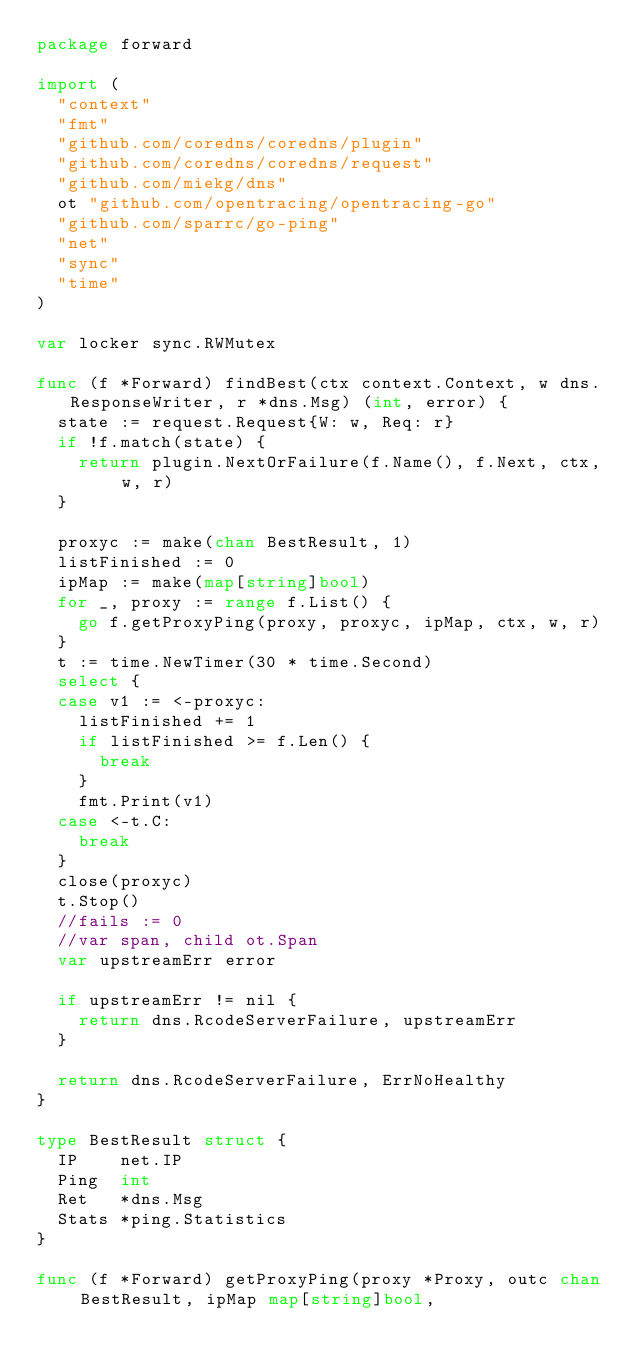Convert code to text. <code><loc_0><loc_0><loc_500><loc_500><_Go_>package forward

import (
	"context"
	"fmt"
	"github.com/coredns/coredns/plugin"
	"github.com/coredns/coredns/request"
	"github.com/miekg/dns"
	ot "github.com/opentracing/opentracing-go"
	"github.com/sparrc/go-ping"
	"net"
	"sync"
	"time"
)

var locker sync.RWMutex

func (f *Forward) findBest(ctx context.Context, w dns.ResponseWriter, r *dns.Msg) (int, error) {
	state := request.Request{W: w, Req: r}
	if !f.match(state) {
		return plugin.NextOrFailure(f.Name(), f.Next, ctx, w, r)
	}

	proxyc := make(chan BestResult, 1)
	listFinished := 0
	ipMap := make(map[string]bool)
	for _, proxy := range f.List() {
		go f.getProxyPing(proxy, proxyc, ipMap, ctx, w, r)
	}
	t := time.NewTimer(30 * time.Second)
	select {
	case v1 := <-proxyc:
		listFinished += 1
		if listFinished >= f.Len() {
			break
		}
		fmt.Print(v1)
	case <-t.C:
		break
	}
	close(proxyc)
	t.Stop()
	//fails := 0
	//var span, child ot.Span
	var upstreamErr error

	if upstreamErr != nil {
		return dns.RcodeServerFailure, upstreamErr
	}

	return dns.RcodeServerFailure, ErrNoHealthy
}

type BestResult struct {
	IP    net.IP
	Ping  int
	Ret   *dns.Msg
	Stats *ping.Statistics
}

func (f *Forward) getProxyPing(proxy *Proxy, outc chan BestResult, ipMap map[string]bool,</code> 